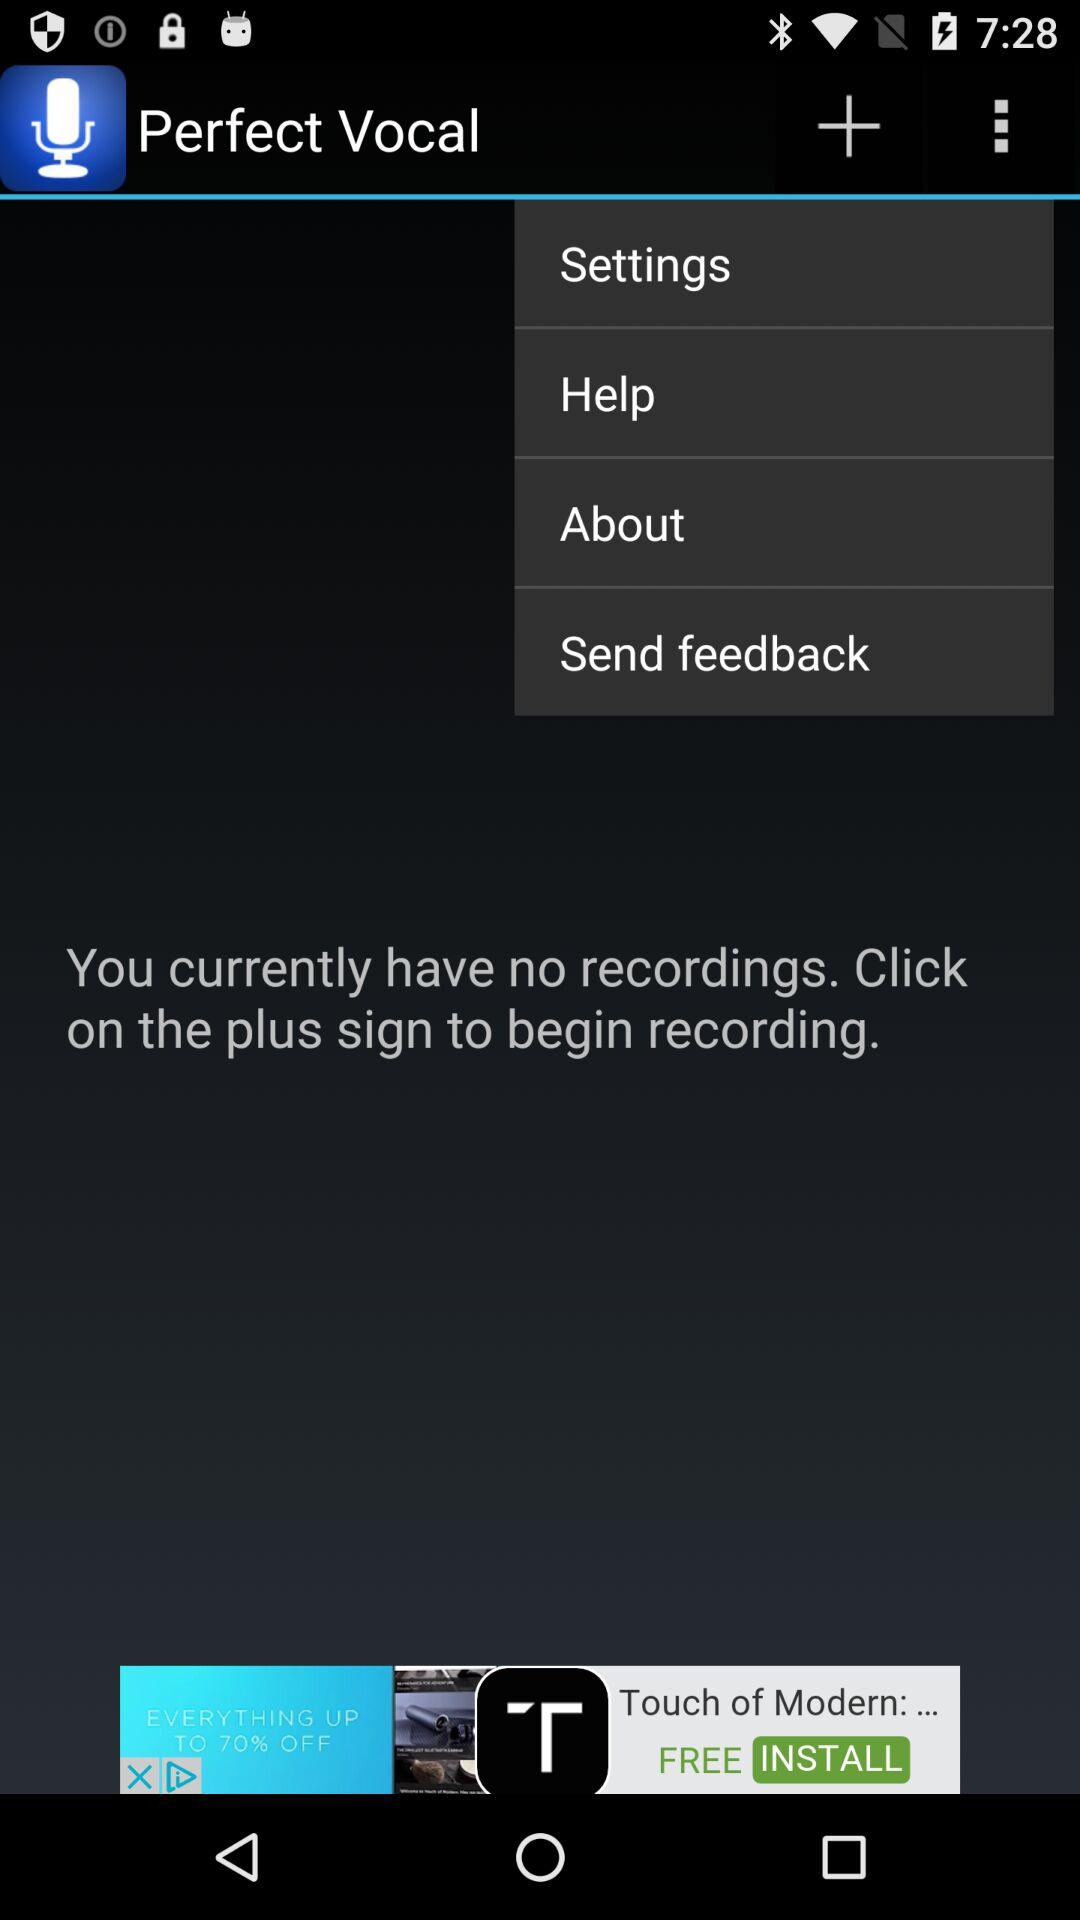What to do to begin recording? To begin recording, click on the plus sign. 